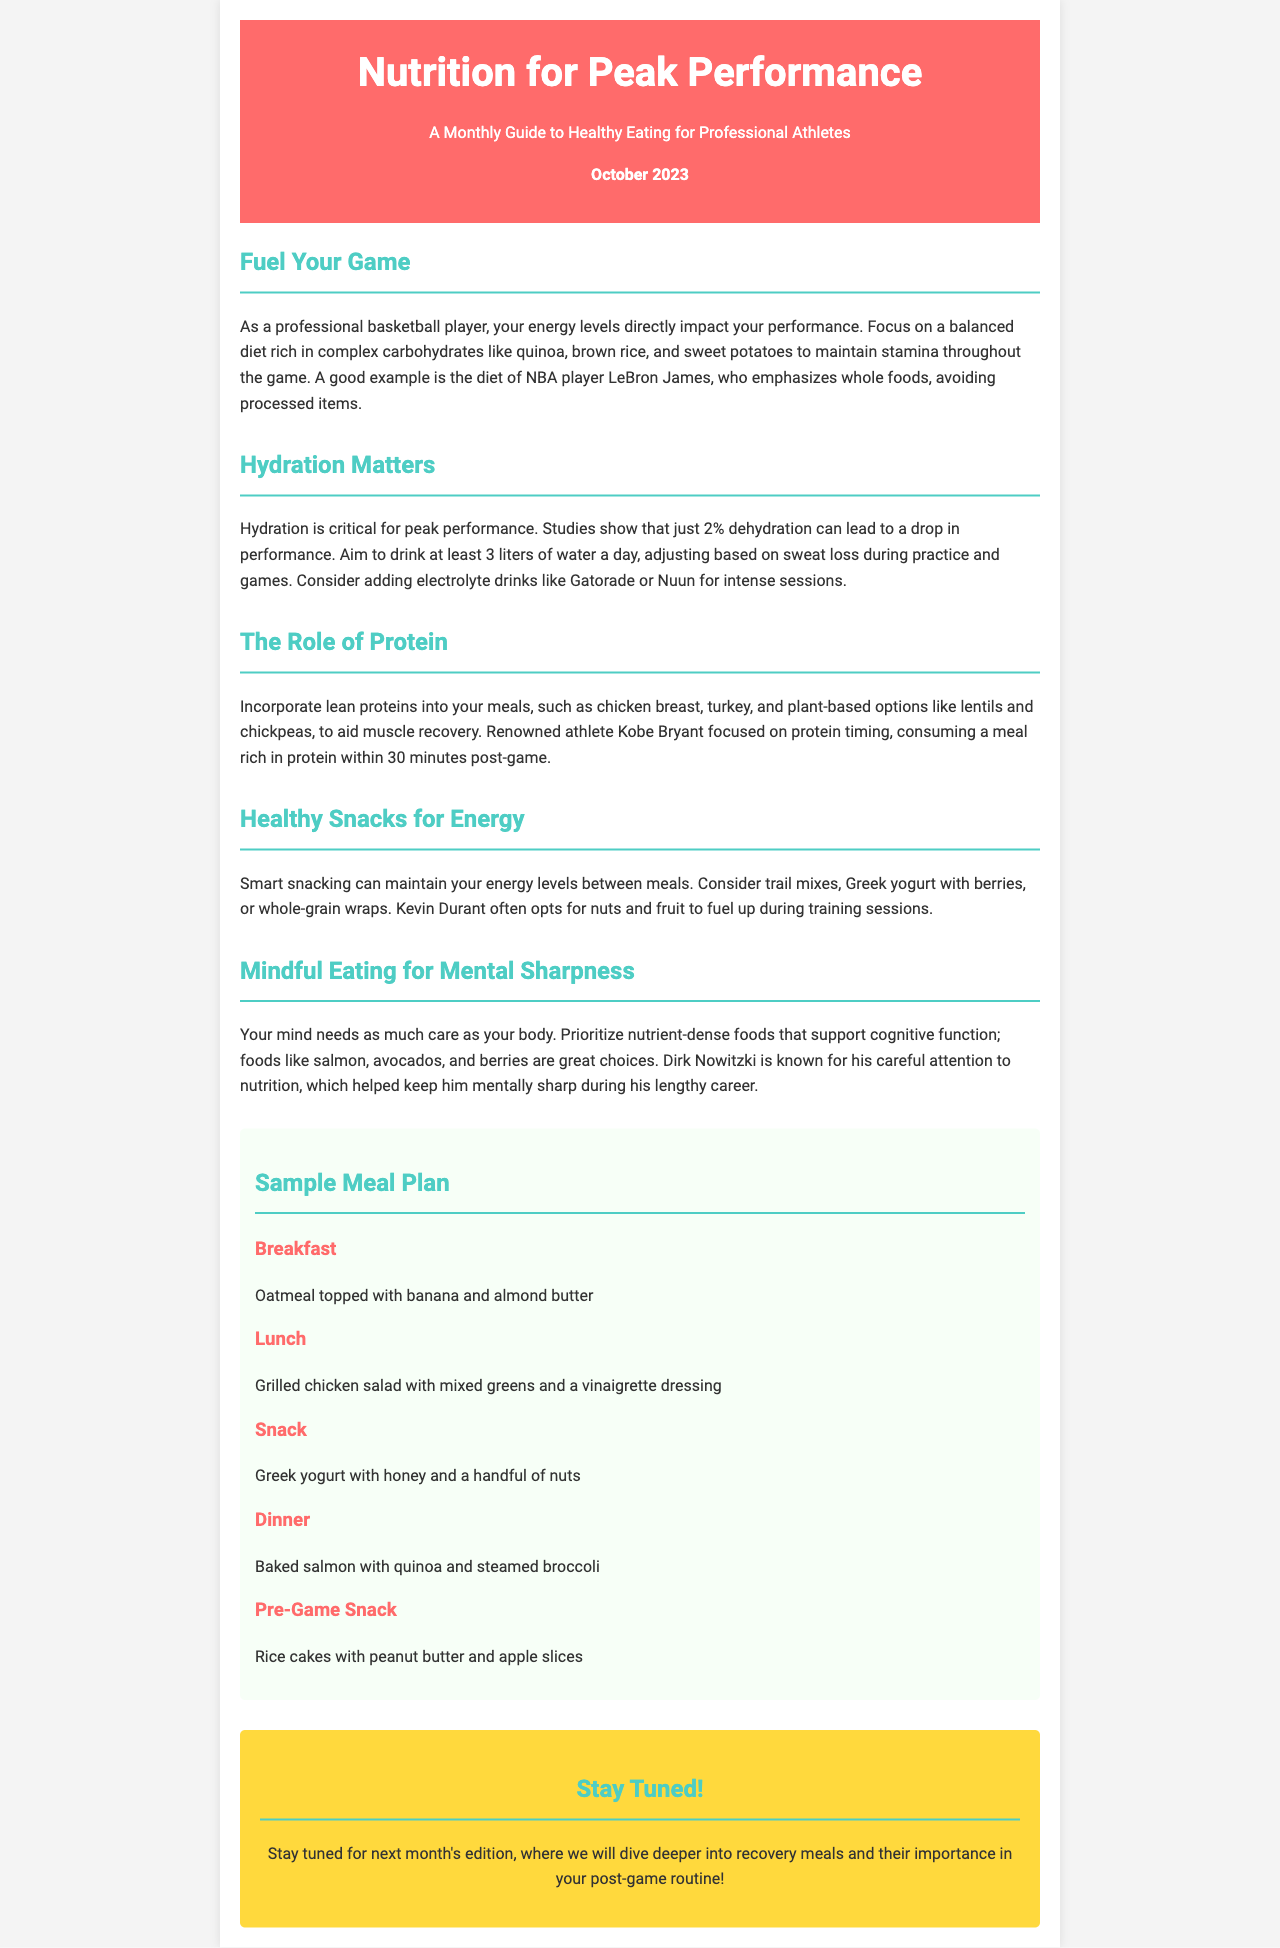What is the publication month and year of this newsletter? The newsletter is dated October 2023, as stated in the header section.
Answer: October 2023 How many liters of water should athletes aim to drink daily? The document specifies that athletes should aim to drink at least 3 liters of water a day.
Answer: 3 liters What type of foods does LeBron James emphasize in his diet? According to the newsletter, LeBron James emphasizes whole foods, avoiding processed items.
Answer: Whole foods What is a recommended pre-game snack mentioned in the meal plan? The sample meal plan includes rice cakes with peanut butter and apple slices as a pre-game snack.
Answer: Rice cakes with peanut butter and apple slices Which nutrient-dense foods are suggested for mental sharpness? Foods like salmon, avocados, and berries are recommended for supporting cognitive function.
Answer: Salmon, avocados, and berries What is the primary focus of this monthly guide? The newsletter is focused on healthy eating for professional athletes, aiming for peak performance.
Answer: Healthy eating for professional athletes Which professional athlete is associated with mindful eating in the document? Dirk Nowitzki is mentioned as an athlete known for his careful attention to nutrition.
Answer: Dirk Nowitzki What meal includes baked salmon according to the sample meal plan? The sample meal plan specifies that baked salmon is included in the dinner section.
Answer: Dinner 